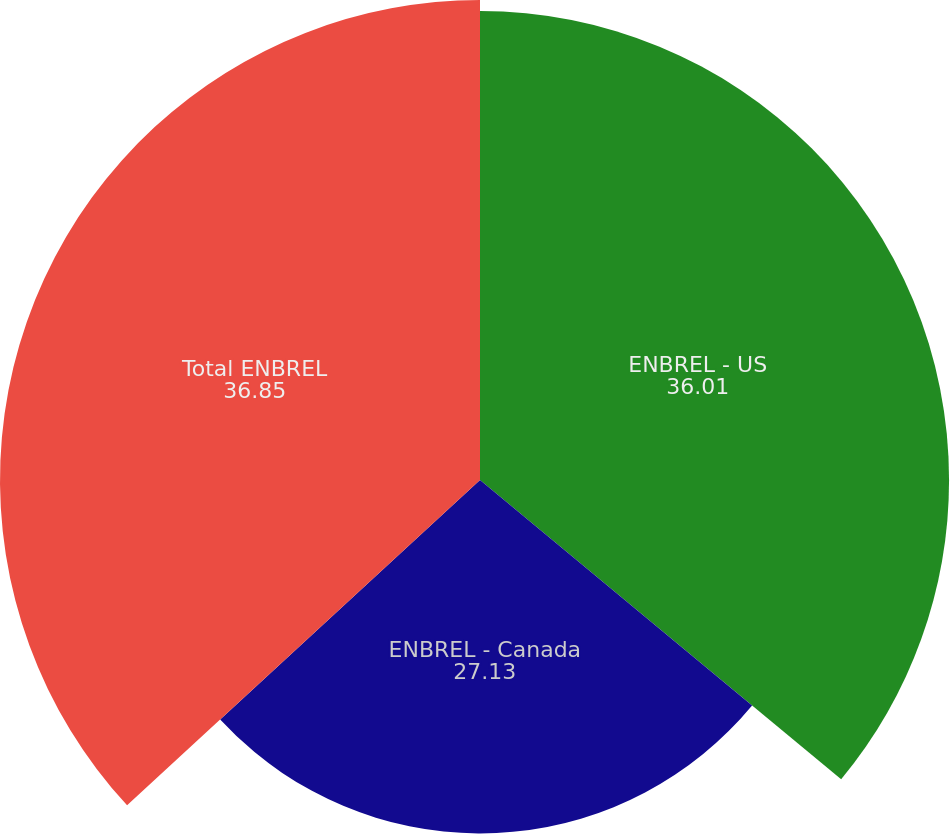<chart> <loc_0><loc_0><loc_500><loc_500><pie_chart><fcel>ENBREL - US<fcel>ENBREL - Canada<fcel>Total ENBREL<nl><fcel>36.01%<fcel>27.13%<fcel>36.85%<nl></chart> 